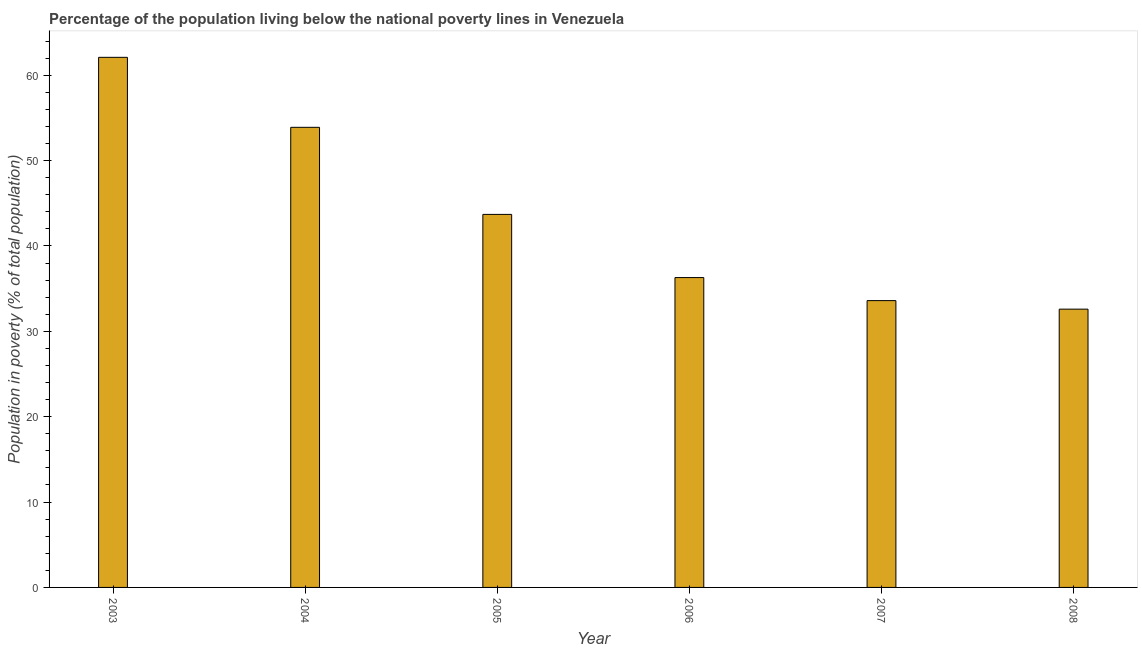Does the graph contain any zero values?
Ensure brevity in your answer.  No. What is the title of the graph?
Offer a terse response. Percentage of the population living below the national poverty lines in Venezuela. What is the label or title of the Y-axis?
Keep it short and to the point. Population in poverty (% of total population). What is the percentage of population living below poverty line in 2008?
Your response must be concise. 32.6. Across all years, what is the maximum percentage of population living below poverty line?
Make the answer very short. 62.1. Across all years, what is the minimum percentage of population living below poverty line?
Your response must be concise. 32.6. In which year was the percentage of population living below poverty line maximum?
Your response must be concise. 2003. What is the sum of the percentage of population living below poverty line?
Provide a succinct answer. 262.2. What is the difference between the percentage of population living below poverty line in 2006 and 2007?
Make the answer very short. 2.7. What is the average percentage of population living below poverty line per year?
Provide a short and direct response. 43.7. What is the median percentage of population living below poverty line?
Provide a succinct answer. 40. Do a majority of the years between 2008 and 2004 (inclusive) have percentage of population living below poverty line greater than 10 %?
Make the answer very short. Yes. What is the ratio of the percentage of population living below poverty line in 2003 to that in 2007?
Your answer should be compact. 1.85. What is the difference between the highest and the second highest percentage of population living below poverty line?
Make the answer very short. 8.2. What is the difference between the highest and the lowest percentage of population living below poverty line?
Offer a very short reply. 29.5. What is the Population in poverty (% of total population) in 2003?
Keep it short and to the point. 62.1. What is the Population in poverty (% of total population) in 2004?
Provide a succinct answer. 53.9. What is the Population in poverty (% of total population) in 2005?
Give a very brief answer. 43.7. What is the Population in poverty (% of total population) of 2006?
Offer a terse response. 36.3. What is the Population in poverty (% of total population) of 2007?
Keep it short and to the point. 33.6. What is the Population in poverty (% of total population) in 2008?
Your response must be concise. 32.6. What is the difference between the Population in poverty (% of total population) in 2003 and 2006?
Offer a terse response. 25.8. What is the difference between the Population in poverty (% of total population) in 2003 and 2007?
Offer a very short reply. 28.5. What is the difference between the Population in poverty (% of total population) in 2003 and 2008?
Your answer should be very brief. 29.5. What is the difference between the Population in poverty (% of total population) in 2004 and 2005?
Keep it short and to the point. 10.2. What is the difference between the Population in poverty (% of total population) in 2004 and 2007?
Keep it short and to the point. 20.3. What is the difference between the Population in poverty (% of total population) in 2004 and 2008?
Give a very brief answer. 21.3. What is the difference between the Population in poverty (% of total population) in 2005 and 2008?
Your answer should be compact. 11.1. What is the difference between the Population in poverty (% of total population) in 2006 and 2007?
Provide a short and direct response. 2.7. What is the ratio of the Population in poverty (% of total population) in 2003 to that in 2004?
Make the answer very short. 1.15. What is the ratio of the Population in poverty (% of total population) in 2003 to that in 2005?
Give a very brief answer. 1.42. What is the ratio of the Population in poverty (% of total population) in 2003 to that in 2006?
Keep it short and to the point. 1.71. What is the ratio of the Population in poverty (% of total population) in 2003 to that in 2007?
Offer a terse response. 1.85. What is the ratio of the Population in poverty (% of total population) in 2003 to that in 2008?
Give a very brief answer. 1.91. What is the ratio of the Population in poverty (% of total population) in 2004 to that in 2005?
Your response must be concise. 1.23. What is the ratio of the Population in poverty (% of total population) in 2004 to that in 2006?
Your response must be concise. 1.49. What is the ratio of the Population in poverty (% of total population) in 2004 to that in 2007?
Make the answer very short. 1.6. What is the ratio of the Population in poverty (% of total population) in 2004 to that in 2008?
Offer a very short reply. 1.65. What is the ratio of the Population in poverty (% of total population) in 2005 to that in 2006?
Your answer should be compact. 1.2. What is the ratio of the Population in poverty (% of total population) in 2005 to that in 2007?
Make the answer very short. 1.3. What is the ratio of the Population in poverty (% of total population) in 2005 to that in 2008?
Provide a short and direct response. 1.34. What is the ratio of the Population in poverty (% of total population) in 2006 to that in 2007?
Make the answer very short. 1.08. What is the ratio of the Population in poverty (% of total population) in 2006 to that in 2008?
Make the answer very short. 1.11. What is the ratio of the Population in poverty (% of total population) in 2007 to that in 2008?
Your response must be concise. 1.03. 